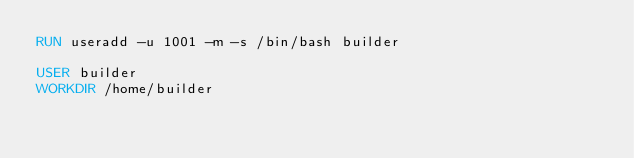Convert code to text. <code><loc_0><loc_0><loc_500><loc_500><_Dockerfile_>RUN useradd -u 1001 -m -s /bin/bash builder

USER builder
WORKDIR /home/builder

</code> 